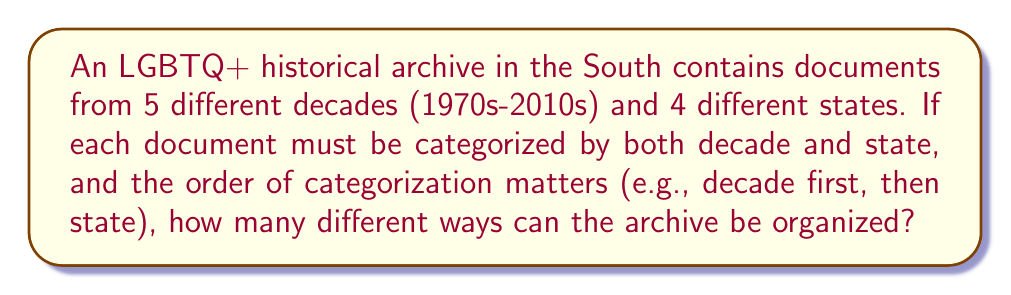Could you help me with this problem? To solve this problem, we need to use the multiplication principle of counting. Here's the step-by-step solution:

1) We have two choices to make for each document:
   a) Which decade category to place it in
   b) Which state category to place it in

2) For the decade categorization, we have 5 choices (1970s, 1980s, 1990s, 2000s, 2010s).

3) For the state categorization, we have 4 choices (4 different states).

4) Since the order of categorization matters (decade first, then state), we multiply these choices:

   $$ 5 \times 4 = 20 $$

5) This means that for each document, there are 20 possible ways to categorize it.

6) However, the question asks about organizing the entire archive. This means we're looking at a permutation of these 20 possibilities.

7) The number of permutations of 20 distinct items is given by 20!:

   $$ 20! = 20 \times 19 \times 18 \times ... \times 2 \times 1 $$

8) We can calculate this:

   $$ 20! = 2,432,902,008,176,640,000 $$

Therefore, there are 2,432,902,008,176,640,000 different ways to organize the archive.
Answer: $20! = 2,432,902,008,176,640,000$ 